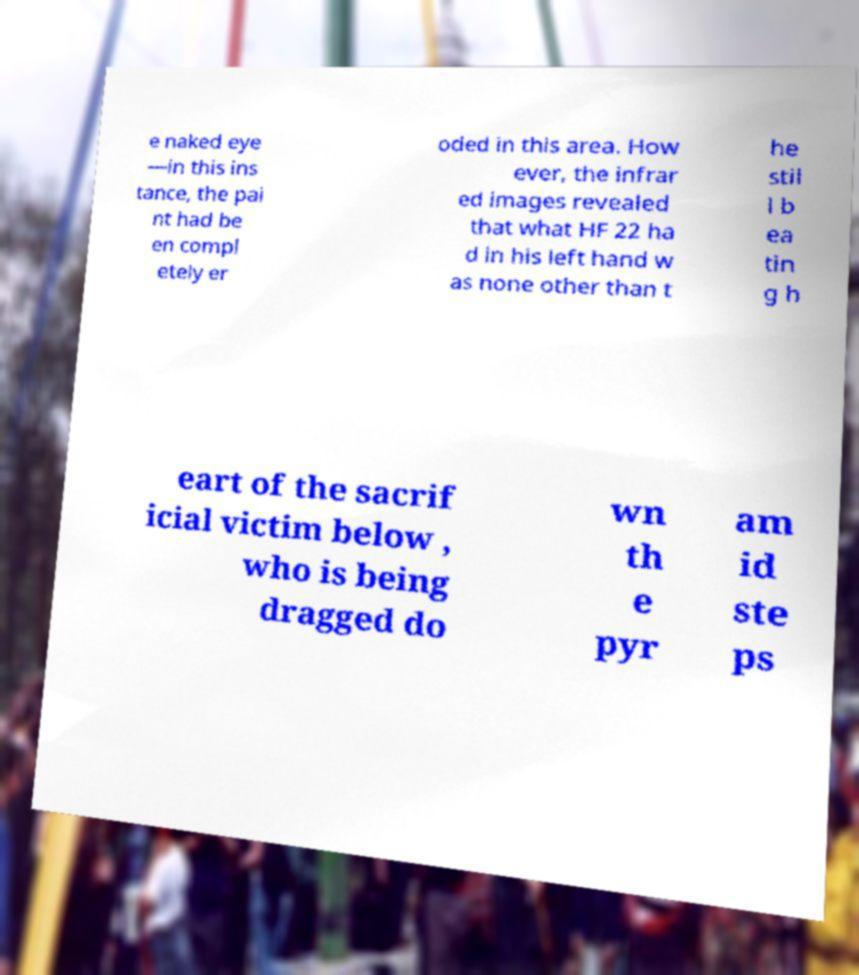There's text embedded in this image that I need extracted. Can you transcribe it verbatim? e naked eye —in this ins tance, the pai nt had be en compl etely er oded in this area. How ever, the infrar ed images revealed that what HF 22 ha d in his left hand w as none other than t he stil l b ea tin g h eart of the sacrif icial victim below , who is being dragged do wn th e pyr am id ste ps 